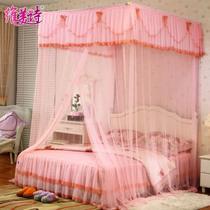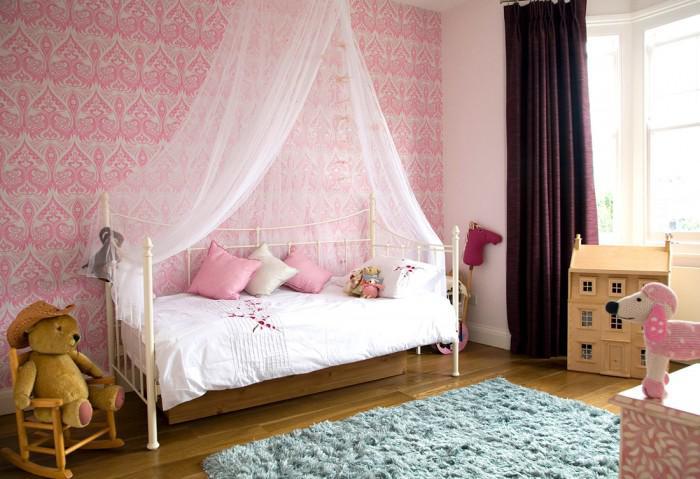The first image is the image on the left, the second image is the image on the right. Assess this claim about the two images: "The bed in one of the images is surrounded by purple netting". Correct or not? Answer yes or no. No. The first image is the image on the left, the second image is the image on the right. Given the left and right images, does the statement "All bed canopies are the same shape as the bed with a deep ruffle at the top and sheer curtains draping down." hold true? Answer yes or no. No. 